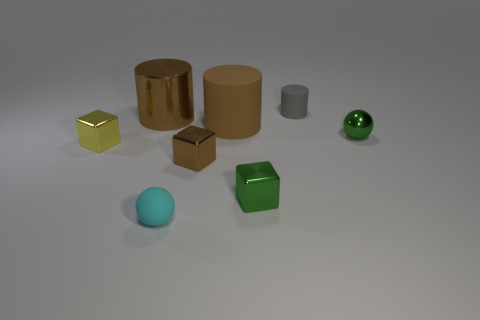Is there anything else that has the same size as the cyan ball?
Your answer should be very brief. Yes. What number of objects are either large brown matte objects or shiny things on the left side of the gray cylinder?
Offer a terse response. 5. Does the sphere behind the small green block have the same color as the metallic cylinder?
Make the answer very short. No. Is the number of green shiny cubes on the left side of the small cyan sphere greater than the number of small metal spheres in front of the tiny brown object?
Your answer should be very brief. No. Is there anything else that is the same color as the large metal cylinder?
Your response must be concise. Yes. What number of objects are purple metal things or small green metal blocks?
Your answer should be compact. 1. There is a metallic block behind the brown cube; is it the same size as the tiny cylinder?
Give a very brief answer. Yes. What number of other objects are the same size as the yellow metal thing?
Offer a terse response. 5. Are any large metallic cylinders visible?
Your response must be concise. Yes. There is a green shiny thing to the left of the sphere behind the small brown cube; how big is it?
Provide a short and direct response. Small. 